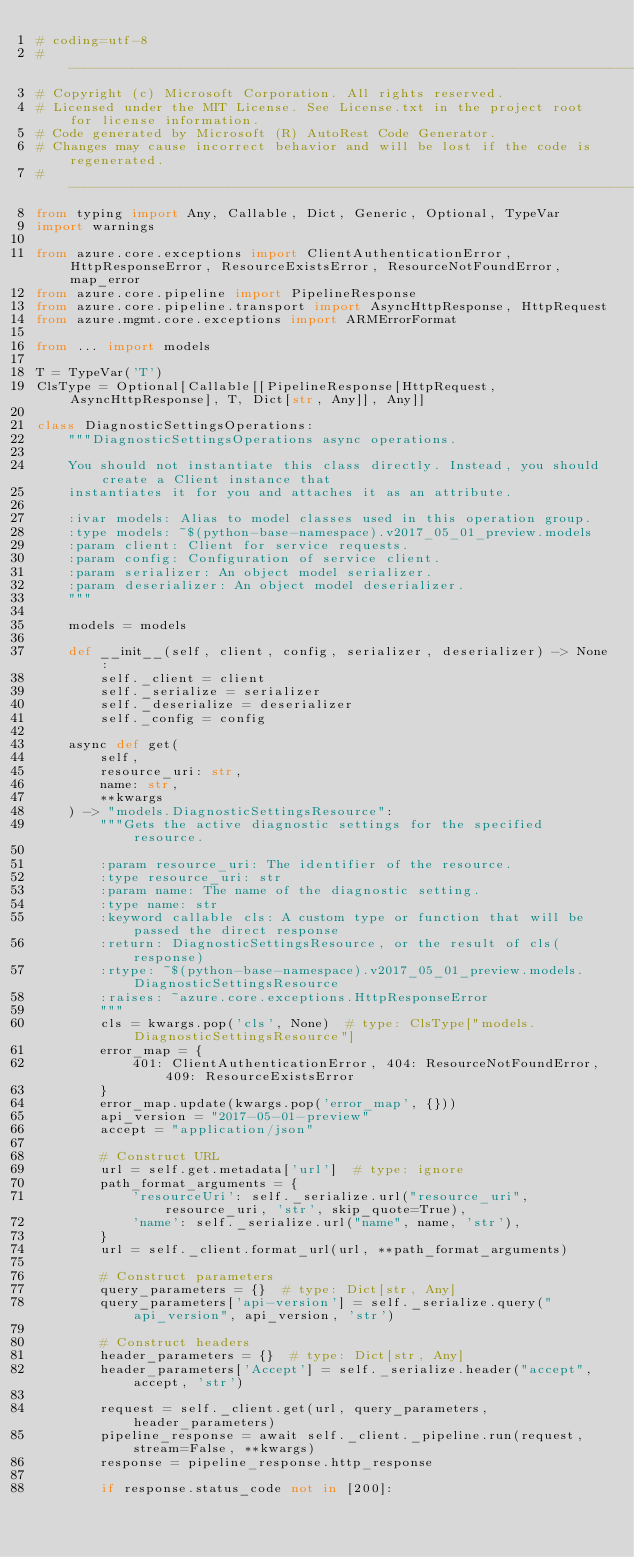<code> <loc_0><loc_0><loc_500><loc_500><_Python_># coding=utf-8
# --------------------------------------------------------------------------
# Copyright (c) Microsoft Corporation. All rights reserved.
# Licensed under the MIT License. See License.txt in the project root for license information.
# Code generated by Microsoft (R) AutoRest Code Generator.
# Changes may cause incorrect behavior and will be lost if the code is regenerated.
# --------------------------------------------------------------------------
from typing import Any, Callable, Dict, Generic, Optional, TypeVar
import warnings

from azure.core.exceptions import ClientAuthenticationError, HttpResponseError, ResourceExistsError, ResourceNotFoundError, map_error
from azure.core.pipeline import PipelineResponse
from azure.core.pipeline.transport import AsyncHttpResponse, HttpRequest
from azure.mgmt.core.exceptions import ARMErrorFormat

from ... import models

T = TypeVar('T')
ClsType = Optional[Callable[[PipelineResponse[HttpRequest, AsyncHttpResponse], T, Dict[str, Any]], Any]]

class DiagnosticSettingsOperations:
    """DiagnosticSettingsOperations async operations.

    You should not instantiate this class directly. Instead, you should create a Client instance that
    instantiates it for you and attaches it as an attribute.

    :ivar models: Alias to model classes used in this operation group.
    :type models: ~$(python-base-namespace).v2017_05_01_preview.models
    :param client: Client for service requests.
    :param config: Configuration of service client.
    :param serializer: An object model serializer.
    :param deserializer: An object model deserializer.
    """

    models = models

    def __init__(self, client, config, serializer, deserializer) -> None:
        self._client = client
        self._serialize = serializer
        self._deserialize = deserializer
        self._config = config

    async def get(
        self,
        resource_uri: str,
        name: str,
        **kwargs
    ) -> "models.DiagnosticSettingsResource":
        """Gets the active diagnostic settings for the specified resource.

        :param resource_uri: The identifier of the resource.
        :type resource_uri: str
        :param name: The name of the diagnostic setting.
        :type name: str
        :keyword callable cls: A custom type or function that will be passed the direct response
        :return: DiagnosticSettingsResource, or the result of cls(response)
        :rtype: ~$(python-base-namespace).v2017_05_01_preview.models.DiagnosticSettingsResource
        :raises: ~azure.core.exceptions.HttpResponseError
        """
        cls = kwargs.pop('cls', None)  # type: ClsType["models.DiagnosticSettingsResource"]
        error_map = {
            401: ClientAuthenticationError, 404: ResourceNotFoundError, 409: ResourceExistsError
        }
        error_map.update(kwargs.pop('error_map', {}))
        api_version = "2017-05-01-preview"
        accept = "application/json"

        # Construct URL
        url = self.get.metadata['url']  # type: ignore
        path_format_arguments = {
            'resourceUri': self._serialize.url("resource_uri", resource_uri, 'str', skip_quote=True),
            'name': self._serialize.url("name", name, 'str'),
        }
        url = self._client.format_url(url, **path_format_arguments)

        # Construct parameters
        query_parameters = {}  # type: Dict[str, Any]
        query_parameters['api-version'] = self._serialize.query("api_version", api_version, 'str')

        # Construct headers
        header_parameters = {}  # type: Dict[str, Any]
        header_parameters['Accept'] = self._serialize.header("accept", accept, 'str')

        request = self._client.get(url, query_parameters, header_parameters)
        pipeline_response = await self._client._pipeline.run(request, stream=False, **kwargs)
        response = pipeline_response.http_response

        if response.status_code not in [200]:</code> 